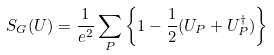Convert formula to latex. <formula><loc_0><loc_0><loc_500><loc_500>S _ { G } ( U ) = \frac { 1 } { e ^ { 2 } } \sum _ { P } \left \{ 1 - \frac { 1 } { 2 } ( U _ { P } + U ^ { \dagger } _ { P } ) \right \}</formula> 